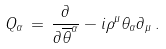<formula> <loc_0><loc_0><loc_500><loc_500>Q _ { \alpha } \, = \, \frac { \partial } { \partial \overline { \theta } ^ { \alpha } } - i \rho ^ { \mu } \theta _ { \alpha } \partial _ { \mu } \, .</formula> 